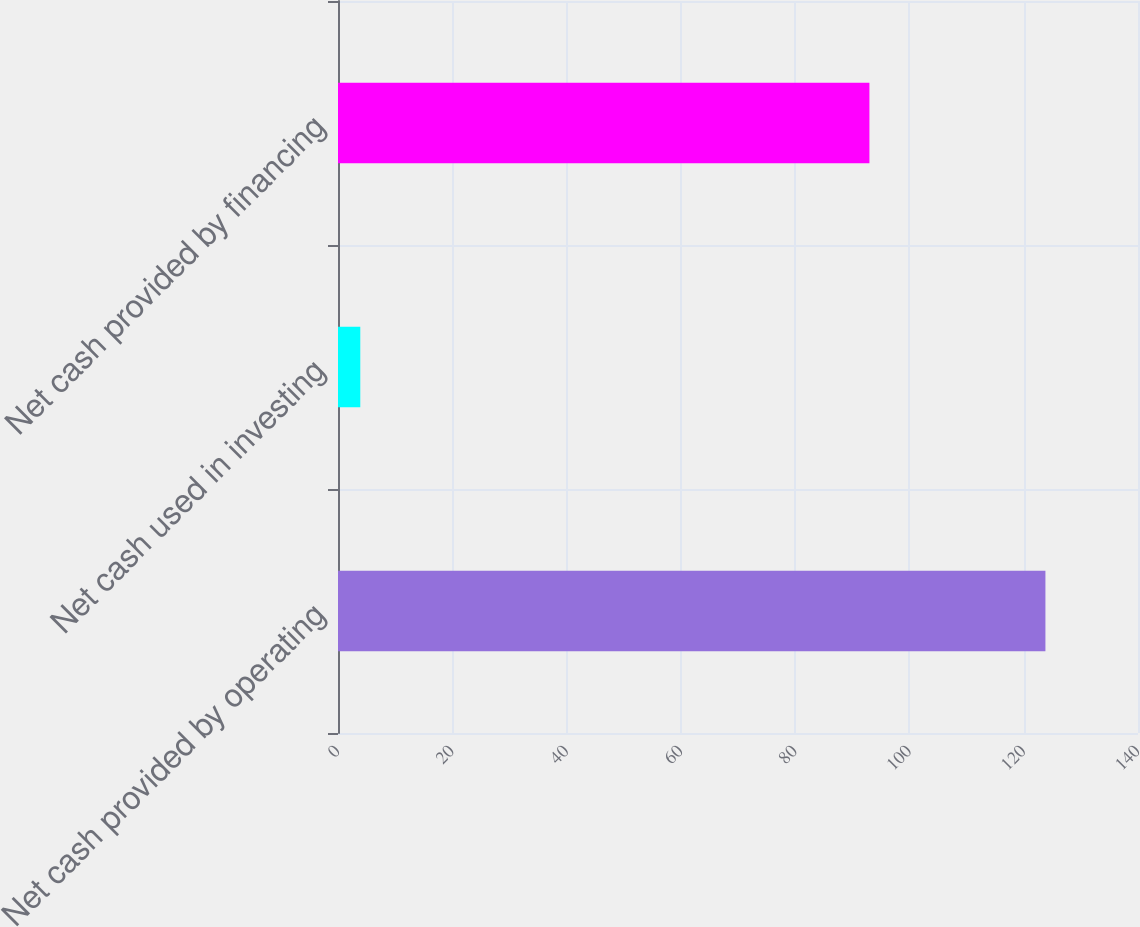<chart> <loc_0><loc_0><loc_500><loc_500><bar_chart><fcel>Net cash provided by operating<fcel>Net cash used in investing<fcel>Net cash provided by financing<nl><fcel>123.8<fcel>3.9<fcel>93<nl></chart> 